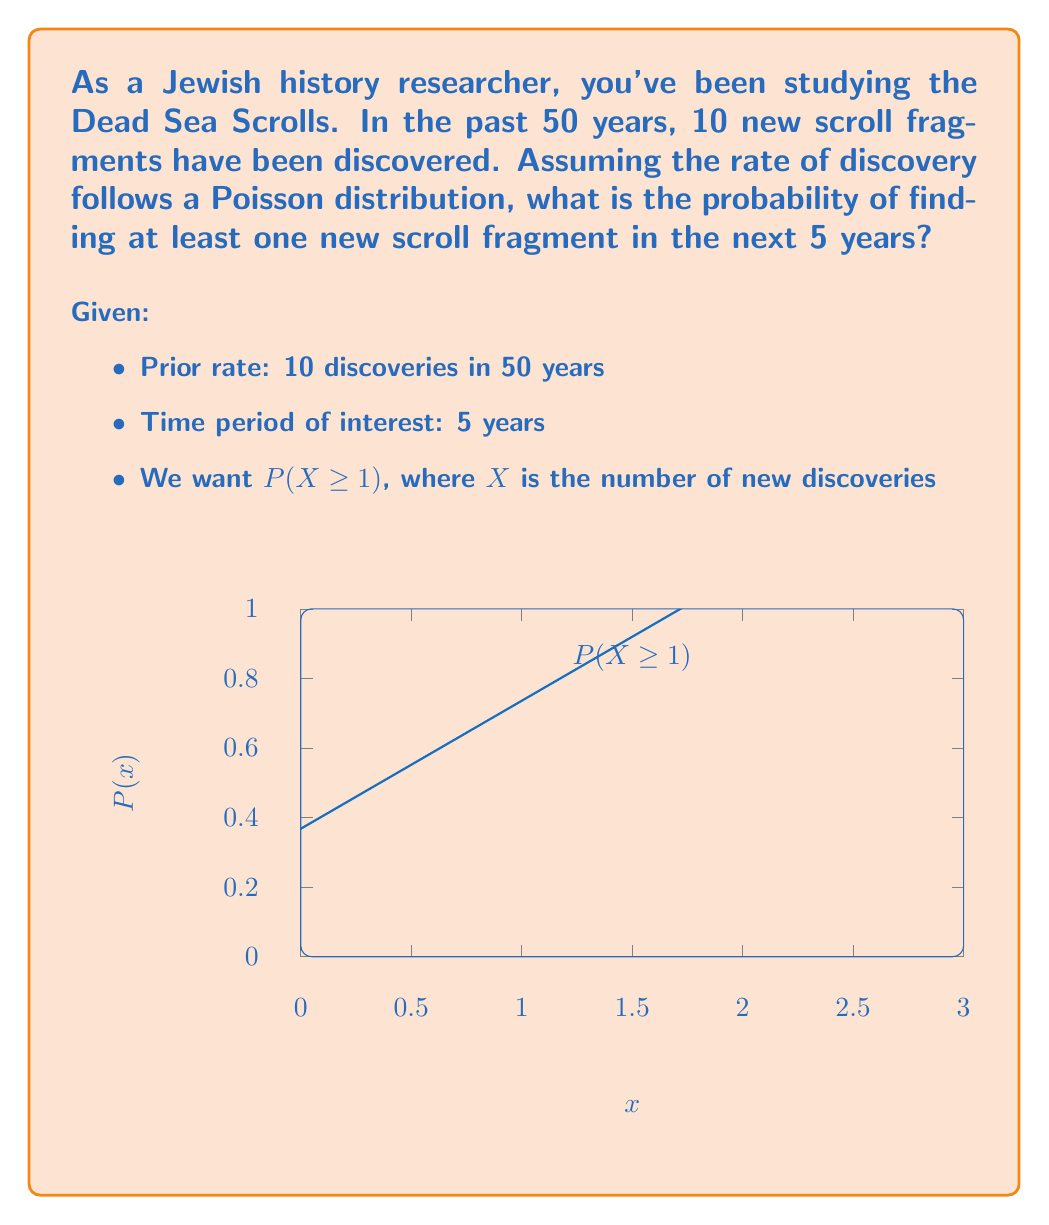Show me your answer to this math problem. Let's approach this step-by-step using the Poisson distribution:

1) First, calculate the rate (λ) for a 5-year period:
   λ = (10 discoveries / 50 years) * 5 years = 1

2) The Poisson distribution gives the probability of x events in a given interval:
   $$P(X = x) = \frac{e^{-λ}λ^x}{x!}$$

3) We want P(X ≥ 1), which is the same as 1 - P(X = 0):
   P(X ≥ 1) = 1 - P(X = 0)

4) Calculate P(X = 0):
   $$P(X = 0) = \frac{e^{-1}1^0}{0!} = e^{-1} ≈ 0.3679$$

5) Therefore:
   P(X ≥ 1) = 1 - P(X = 0)
             = 1 - 0.3679
             ≈ 0.6321

Thus, there is approximately a 63.21% chance of finding at least one new scroll fragment in the next 5 years.
Answer: 0.6321 or 63.21% 